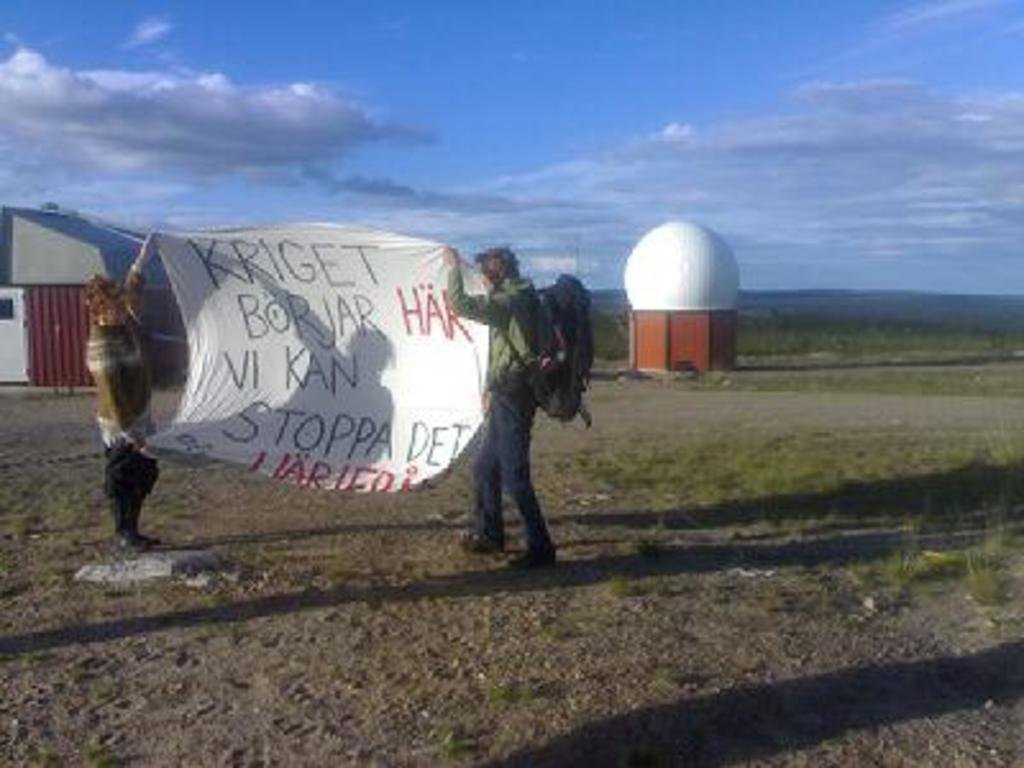How many people are in the image? There are two persons in the image. What are the persons holding in the image? The persons are holding a banner. What can be read on the banner? There is text on the banner. What type of structure is visible in the image? There is a house in the image. What type of vegetation is visible in the image? There is grass visible in the image. What part of the natural environment is visible in the image? The sky is visible in the image. What type of motion can be seen in the image? There is no motion visible in the image; the persons are holding a banner, but they are not moving. What type of arch is present in the image? There is no arch present in the image. 